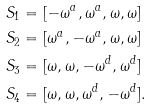<formula> <loc_0><loc_0><loc_500><loc_500>S _ { 1 } & = [ - \omega ^ { a } , \omega ^ { a } , \omega , \omega ] \\ S _ { 2 } & = [ \omega ^ { a } , - \omega ^ { a } , \omega , \omega ] \\ S _ { 3 } & = [ \omega , \omega , - \omega ^ { d } , \omega ^ { d } ] \\ S _ { 4 } & = [ \omega , \omega , \omega ^ { d } , - \omega ^ { d } ] .</formula> 